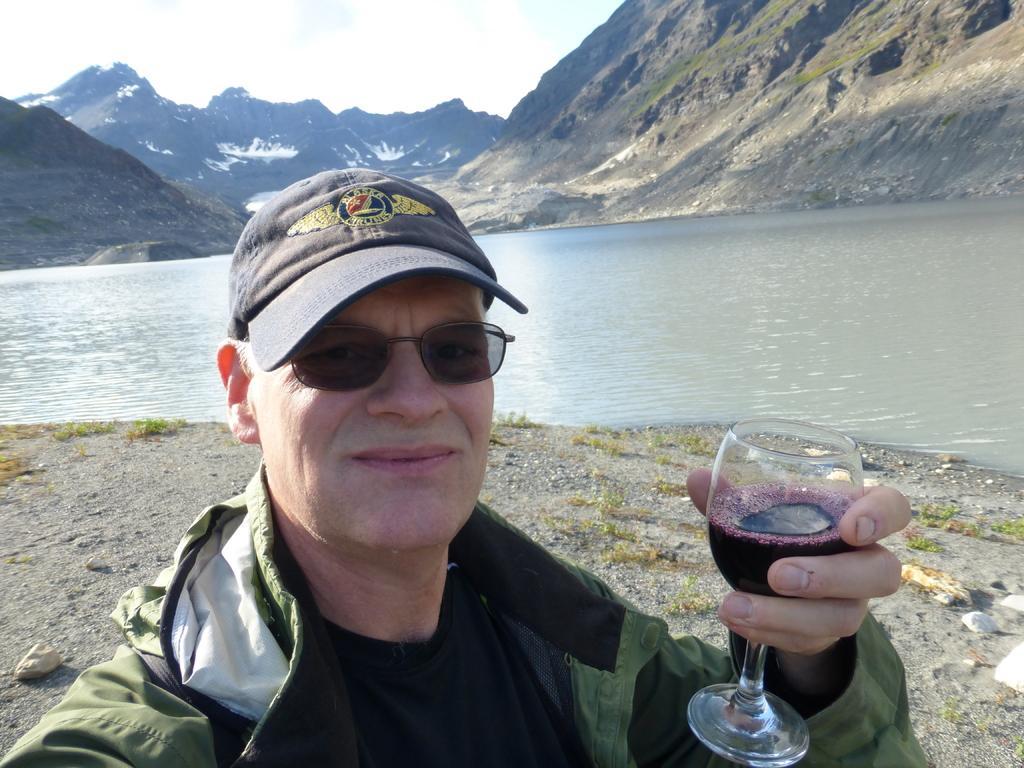Could you give a brief overview of what you see in this image? As we can see in the image there is a sky, hills, water and a man holding glass. 